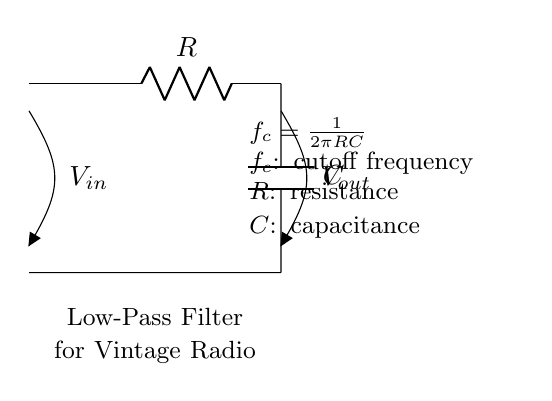What components are in this circuit? The circuit consists of a resistor and a capacitor, which are commonly used in low-pass filter designs. These components are depicted with labels in the circuit diagram.
Answer: Resistor, Capacitor What is the purpose of this circuit? The purpose of the circuit, as indicated in the label, is to serve as a low-pass filter for vintage radio receivers, filtering out high-frequency noise or static.
Answer: Low-pass filter What is the cutoff frequency formula? The formula for the cutoff frequency is shown in the circuit diagram as f_c = 1/(2πRC), which describes how the cutoff frequency depends on the resistance and capacitance values.
Answer: f_c = 1/(2πRC) If the resistance is doubled, how does it affect the cutoff frequency? Doubling the resistance (R) in the cutoff frequency formula f_c = 1/(2πRC) will decrease the cutoff frequency, as the frequency is inversely proportional to resistance.
Answer: Decreases What is the significance of the voltage labels in the circuit? The voltage labels V_in and V_out indicate the input voltage to the filter and the output voltage after filtering, which helps in analyzing the circuit's performance.
Answer: Indicates input and output voltages How does this low-pass filter affect static in a radio receiver? The low-pass filter allows low-frequency signals (like audio) to pass while attenuating high-frequency noise (static), which is beneficial for clear radio reception.
Answer: Reduces static What would happen if the capacitor value is halved? Halving the capacitance (C) in the cutoff frequency formula f_c = 1/(2πRC) will increase the cutoff frequency, allowing more high-frequency signals to pass through the filter.
Answer: Increases cutoff frequency 